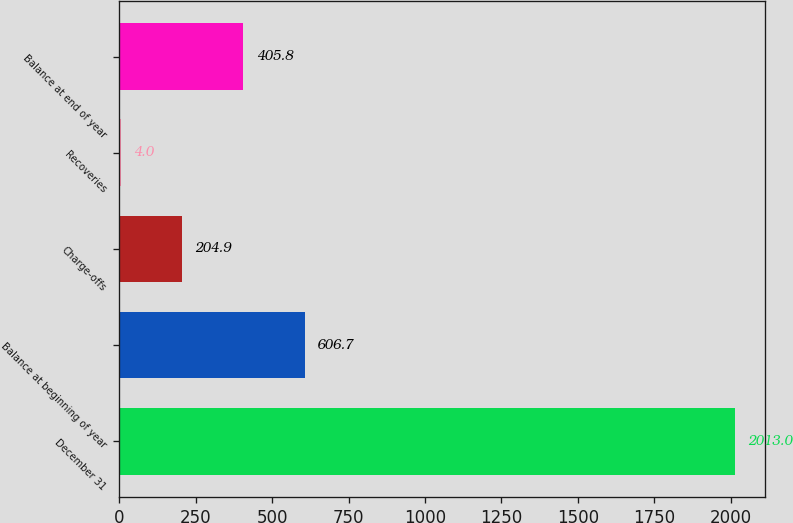<chart> <loc_0><loc_0><loc_500><loc_500><bar_chart><fcel>December 31<fcel>Balance at beginning of year<fcel>Charge-offs<fcel>Recoveries<fcel>Balance at end of year<nl><fcel>2013<fcel>606.7<fcel>204.9<fcel>4<fcel>405.8<nl></chart> 